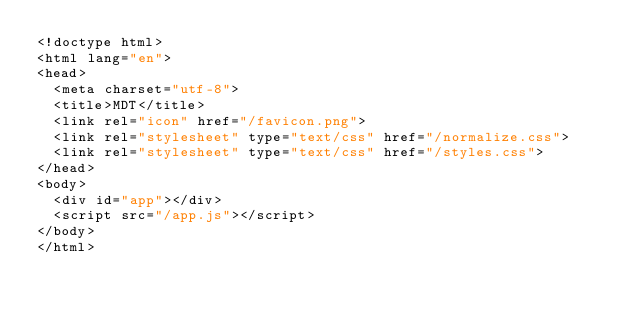<code> <loc_0><loc_0><loc_500><loc_500><_HTML_><!doctype html>
<html lang="en">
<head>
  <meta charset="utf-8">
  <title>MDT</title>
  <link rel="icon" href="/favicon.png">
  <link rel="stylesheet" type="text/css" href="/normalize.css">
  <link rel="stylesheet" type="text/css" href="/styles.css">
</head>
<body>
  <div id="app"></div>
  <script src="/app.js"></script>
</body>
</html>
</code> 